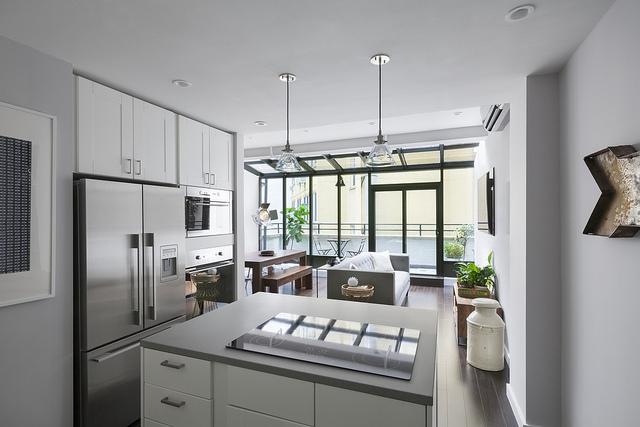How many windows are there in that room?
Give a very brief answer. 15. How many pendant lights are hanging from the ceiling?
Concise answer only. 2. What room of the house would you expect to find this scene in?
Give a very brief answer. Kitchen. Where is the kettle?
Short answer required. Table. Is this an upscale apartment?
Be succinct. Yes. What color is the door?
Quick response, please. Black. Is there a frying pan in the photo?
Give a very brief answer. No. Does someone need to wash dishes?
Concise answer only. No. Is the fridge antique?
Keep it brief. No. Do you like this kitchen?
Be succinct. Yes. Is this a contemporary kitchen?
Keep it brief. Yes. Are there any dishes in the drying rack?
Be succinct. No. What color is the table?
Be succinct. Brown. Could this be an upgraded modern kitchen?
Be succinct. Yes. How many plants are in the picture?
Answer briefly. 4. Was this picture taken in the last 5 years?
Keep it brief. Yes. What color is the wall?
Answer briefly. White. Is this a modern kitchen?
Concise answer only. Yes. 